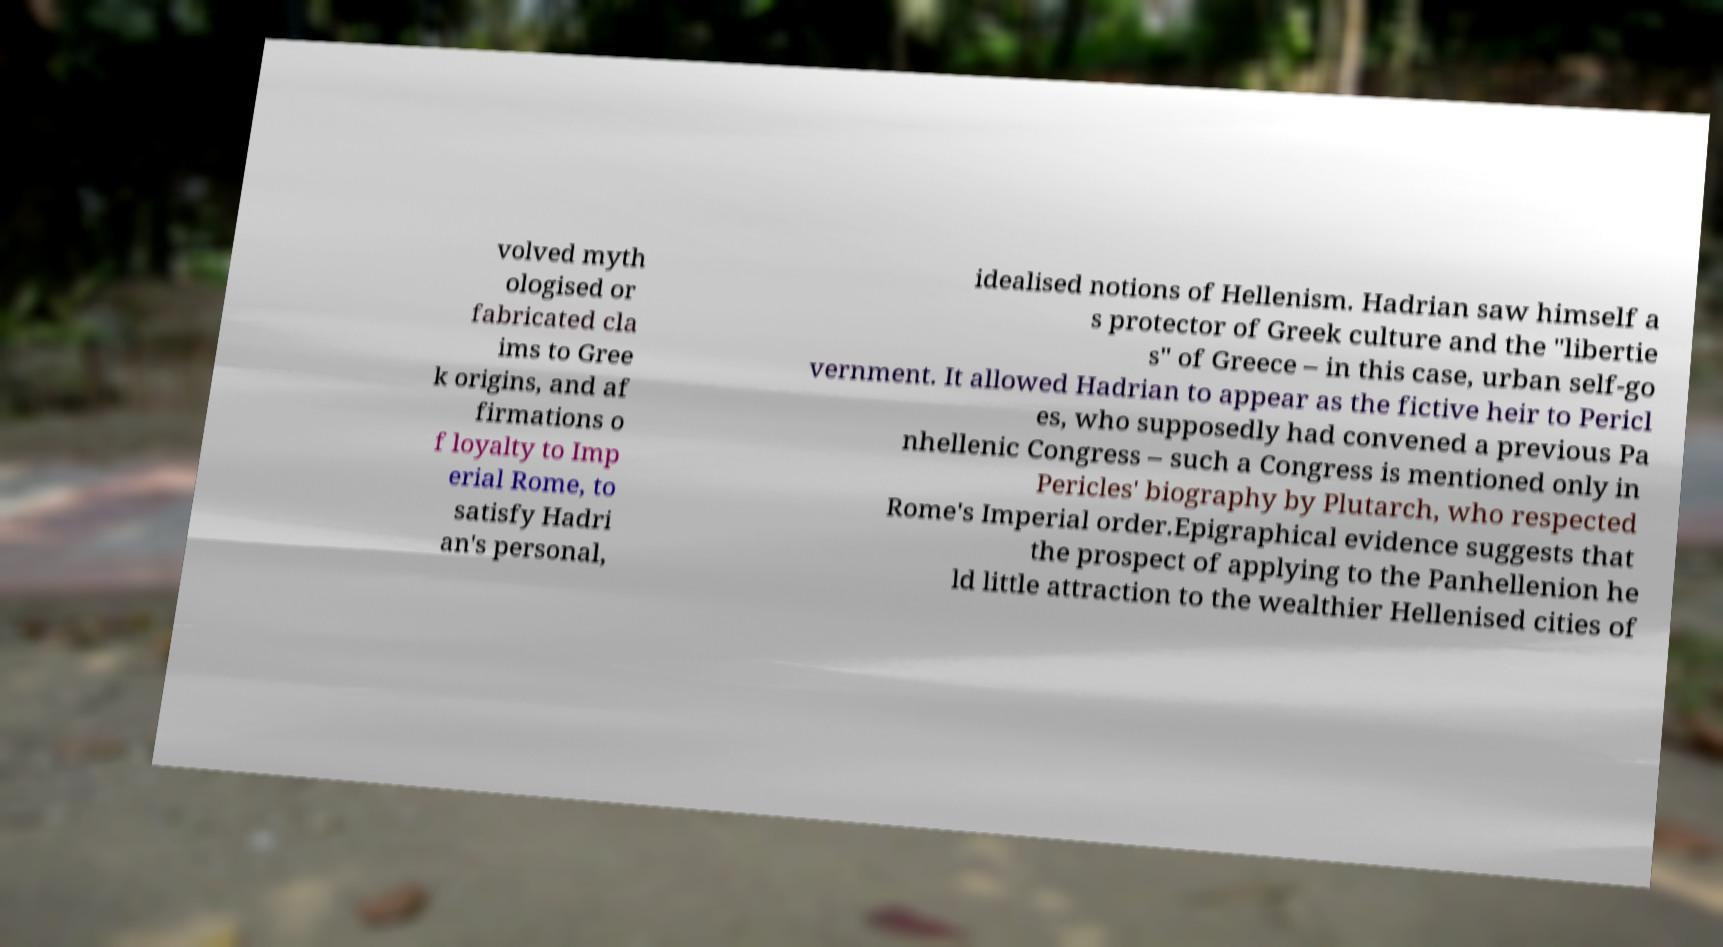Can you accurately transcribe the text from the provided image for me? volved myth ologised or fabricated cla ims to Gree k origins, and af firmations o f loyalty to Imp erial Rome, to satisfy Hadri an's personal, idealised notions of Hellenism. Hadrian saw himself a s protector of Greek culture and the "libertie s" of Greece – in this case, urban self-go vernment. It allowed Hadrian to appear as the fictive heir to Pericl es, who supposedly had convened a previous Pa nhellenic Congress – such a Congress is mentioned only in Pericles' biography by Plutarch, who respected Rome's Imperial order.Epigraphical evidence suggests that the prospect of applying to the Panhellenion he ld little attraction to the wealthier Hellenised cities of 